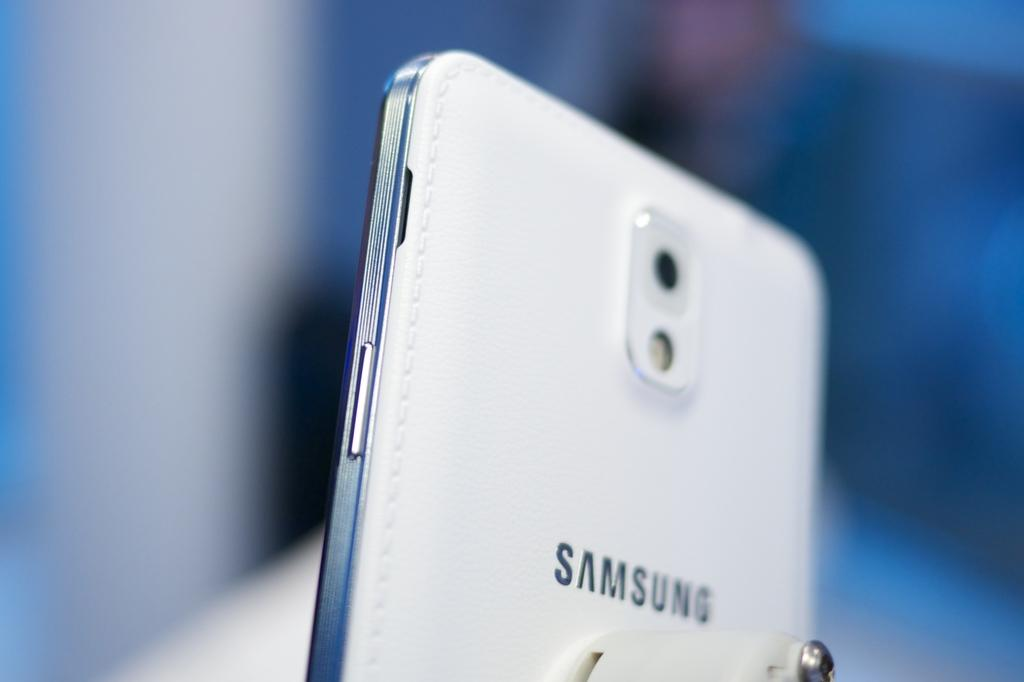Provide a one-sentence caption for the provided image. A white Samsung phone is held at an angle so that the slim feature of the phone is recognizable. 